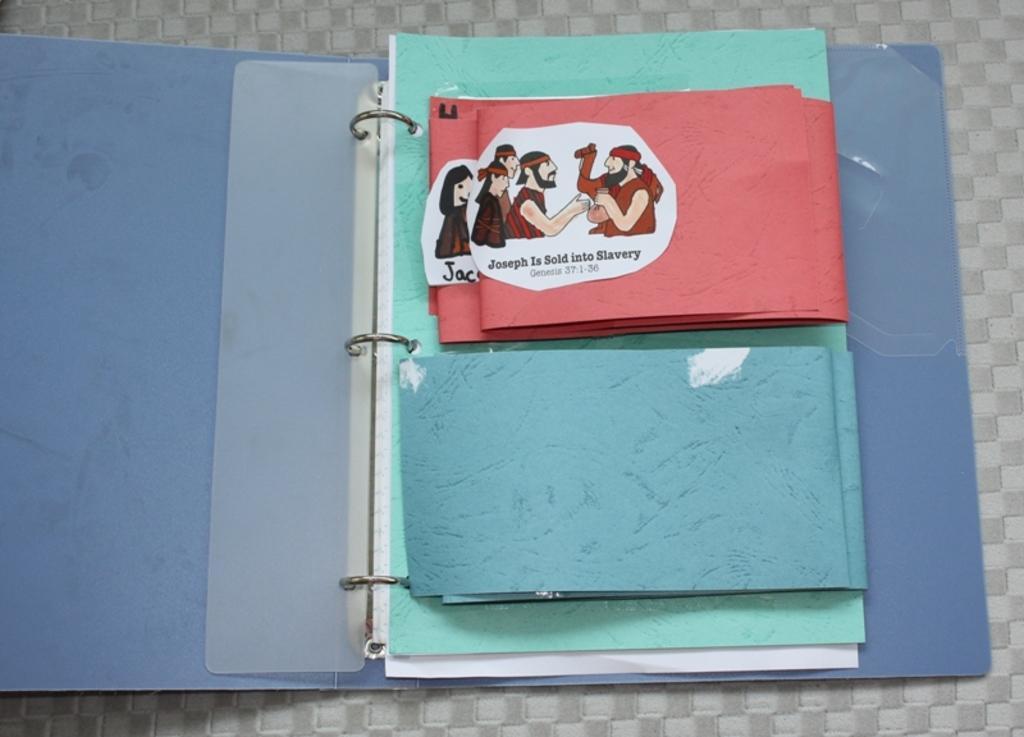Describe this image in one or two sentences. In this image there is a file on a surface. The file is open. There are papers in the file. On a paper there are pictures of a person's, camel and text. 